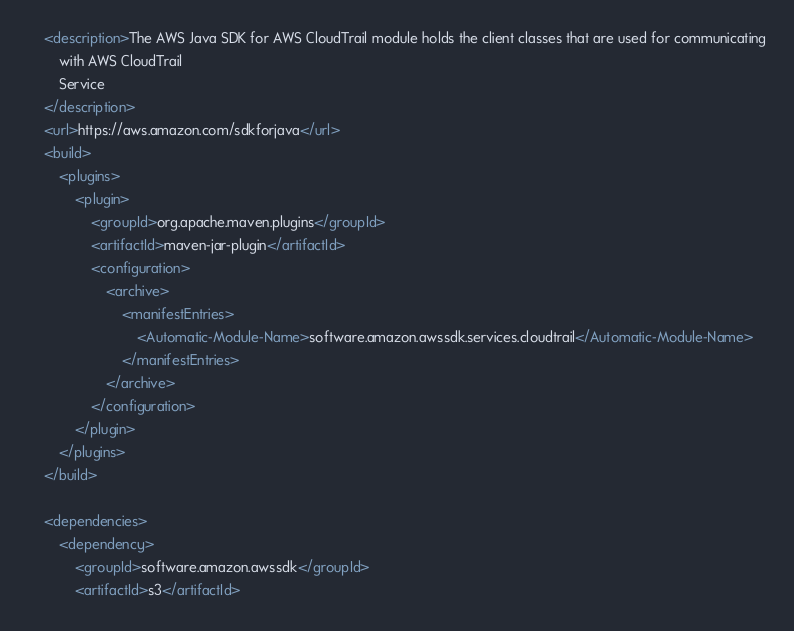Convert code to text. <code><loc_0><loc_0><loc_500><loc_500><_XML_>    <description>The AWS Java SDK for AWS CloudTrail module holds the client classes that are used for communicating
        with AWS CloudTrail
        Service
    </description>
    <url>https://aws.amazon.com/sdkforjava</url>
    <build>
        <plugins>
            <plugin>
                <groupId>org.apache.maven.plugins</groupId>
                <artifactId>maven-jar-plugin</artifactId>
                <configuration>
                    <archive>
                        <manifestEntries>
                            <Automatic-Module-Name>software.amazon.awssdk.services.cloudtrail</Automatic-Module-Name>
                        </manifestEntries>
                    </archive>
                </configuration>
            </plugin>
        </plugins>
    </build>

    <dependencies>
        <dependency>
            <groupId>software.amazon.awssdk</groupId>
            <artifactId>s3</artifactId></code> 